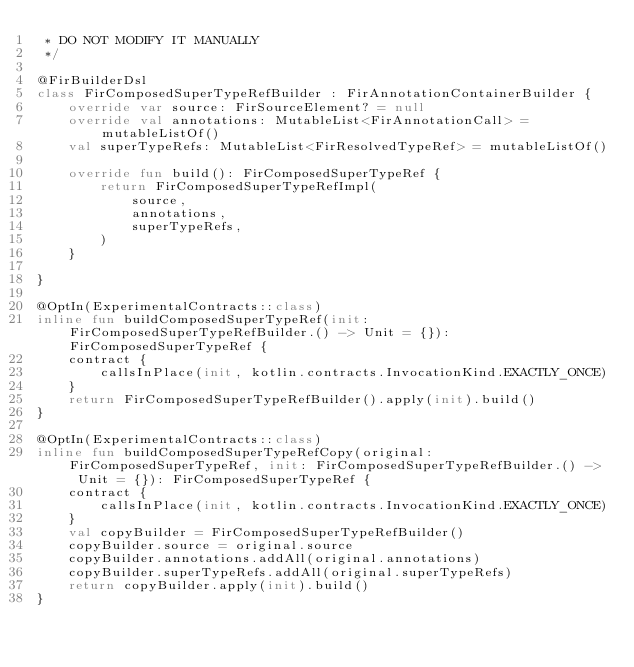Convert code to text. <code><loc_0><loc_0><loc_500><loc_500><_Kotlin_> * DO NOT MODIFY IT MANUALLY
 */

@FirBuilderDsl
class FirComposedSuperTypeRefBuilder : FirAnnotationContainerBuilder {
    override var source: FirSourceElement? = null
    override val annotations: MutableList<FirAnnotationCall> = mutableListOf()
    val superTypeRefs: MutableList<FirResolvedTypeRef> = mutableListOf()

    override fun build(): FirComposedSuperTypeRef {
        return FirComposedSuperTypeRefImpl(
            source,
            annotations,
            superTypeRefs,
        )
    }

}

@OptIn(ExperimentalContracts::class)
inline fun buildComposedSuperTypeRef(init: FirComposedSuperTypeRefBuilder.() -> Unit = {}): FirComposedSuperTypeRef {
    contract {
        callsInPlace(init, kotlin.contracts.InvocationKind.EXACTLY_ONCE)
    }
    return FirComposedSuperTypeRefBuilder().apply(init).build()
}

@OptIn(ExperimentalContracts::class)
inline fun buildComposedSuperTypeRefCopy(original: FirComposedSuperTypeRef, init: FirComposedSuperTypeRefBuilder.() -> Unit = {}): FirComposedSuperTypeRef {
    contract {
        callsInPlace(init, kotlin.contracts.InvocationKind.EXACTLY_ONCE)
    }
    val copyBuilder = FirComposedSuperTypeRefBuilder()
    copyBuilder.source = original.source
    copyBuilder.annotations.addAll(original.annotations)
    copyBuilder.superTypeRefs.addAll(original.superTypeRefs)
    return copyBuilder.apply(init).build()
}
</code> 